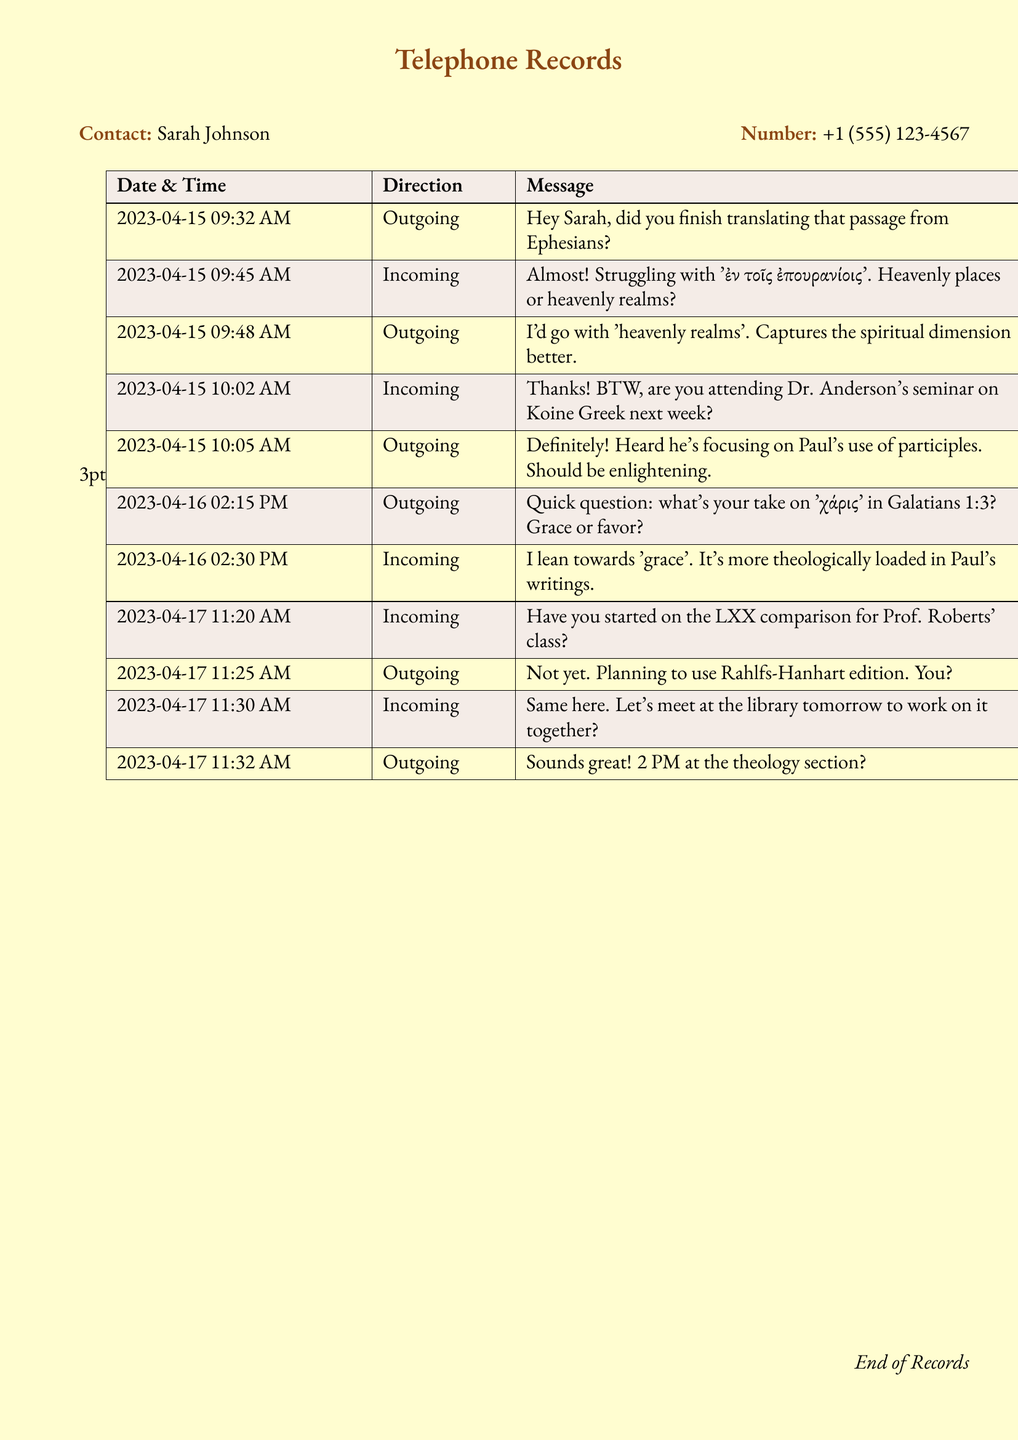What is the name of the contact? The document provides the name of the contact, which is mentioned at the beginning of the records.
Answer: Sarah Johnson What is Sarah's phone number? The contact information includes Sarah's phone number, which is clearly stated in the document.
Answer: +1 (555) 123-4567 What is the date of the first message? The first message's date is listed in the table as the document's records start with it.
Answer: 2023-04-15 What is the topic of Dr. Anderson's seminar? The messages discuss the seminar, and the topic is explicitly mentioned in one of the incoming messages.
Answer: Paul's use of participles Which Greek word is discussed in Galatians 1:3? The conversation references a specific Greek word from the biblical passage in one of the messages.
Answer: χάρις What time is the meeting scheduled at the library? The specific time for the meeting mentioned in the messages is provided.
Answer: 2 PM Which edition of the LXX are the students planning to use? The outgoing message indicates which edition they plan to use for their comparison, providing specific information from the conversation.
Answer: Rahlfs-Hanhart edition What phrase is debated in the translation of Ephesians? The students discuss a specific phrase's translation that indicates the focus of their conversation.
Answer: ἐν τοῖς ἐπουρανίοις 